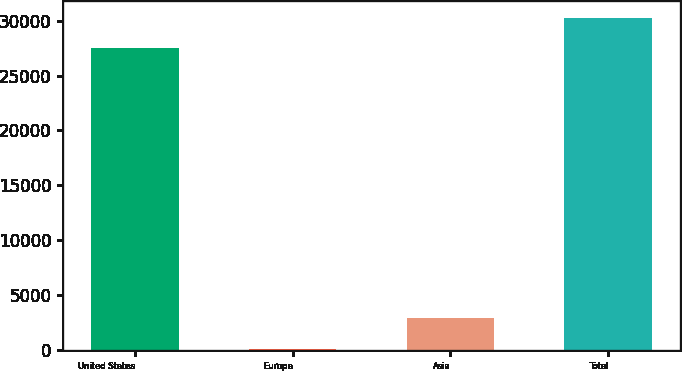Convert chart. <chart><loc_0><loc_0><loc_500><loc_500><bar_chart><fcel>United States<fcel>Europe<fcel>Asia<fcel>Total<nl><fcel>27505<fcel>133<fcel>2906.4<fcel>30278.4<nl></chart> 